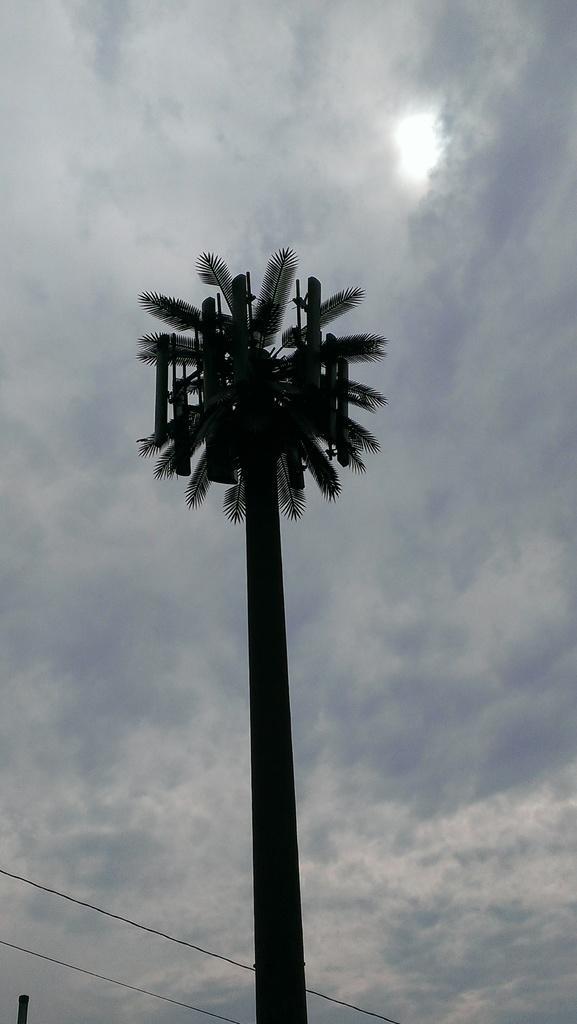Could you give a brief overview of what you see in this image? In the foreground of this image, there is a tree. On the bottom, there are cables. On the top, there is the sky and the cloud. 